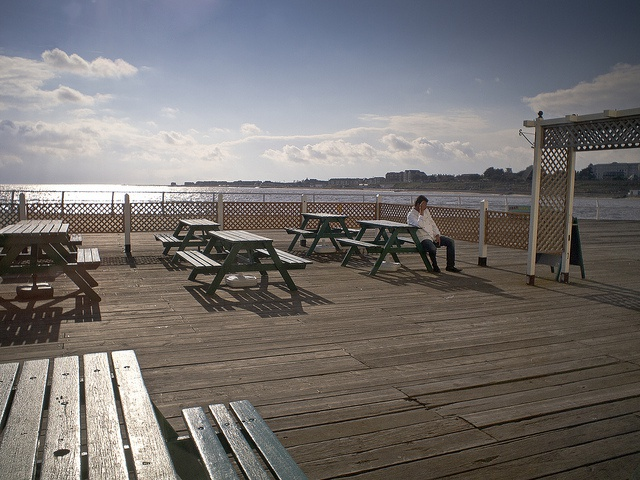Describe the objects in this image and their specific colors. I can see bench in gray, ivory, darkgray, and black tones, bench in gray, black, darkgray, and lightgray tones, bench in gray, black, darkgray, and lightgray tones, bench in gray, black, and darkgray tones, and bench in gray, black, lightgray, and darkgray tones in this image. 